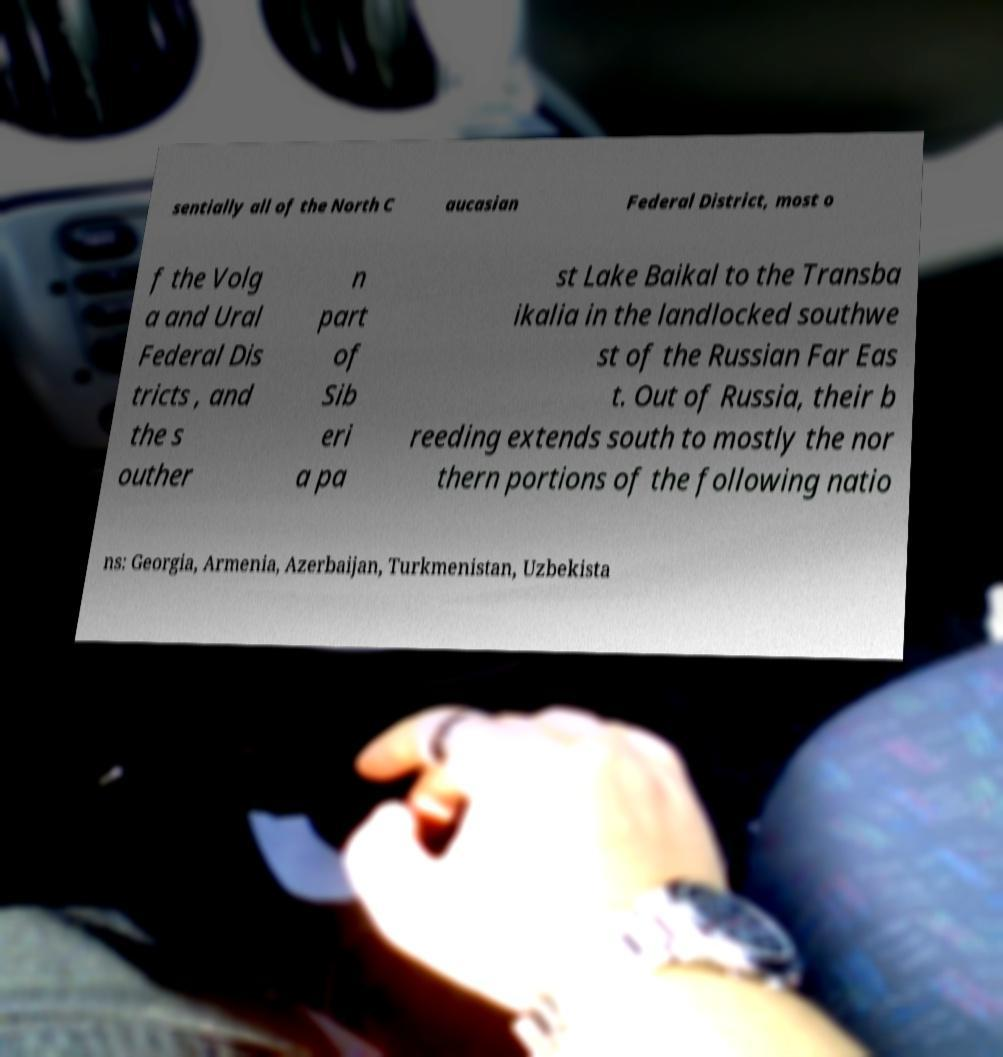Could you extract and type out the text from this image? sentially all of the North C aucasian Federal District, most o f the Volg a and Ural Federal Dis tricts , and the s outher n part of Sib eri a pa st Lake Baikal to the Transba ikalia in the landlocked southwe st of the Russian Far Eas t. Out of Russia, their b reeding extends south to mostly the nor thern portions of the following natio ns: Georgia, Armenia, Azerbaijan, Turkmenistan, Uzbekista 